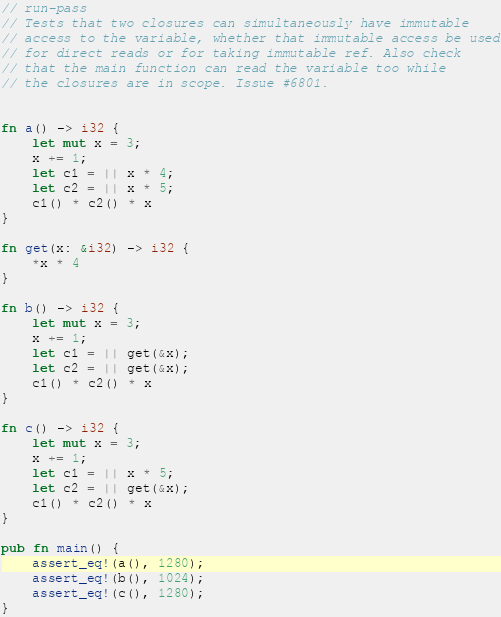<code> <loc_0><loc_0><loc_500><loc_500><_Rust_>// run-pass
// Tests that two closures can simultaneously have immutable
// access to the variable, whether that immutable access be used
// for direct reads or for taking immutable ref. Also check
// that the main function can read the variable too while
// the closures are in scope. Issue #6801.


fn a() -> i32 {
    let mut x = 3;
    x += 1;
    let c1 = || x * 4;
    let c2 = || x * 5;
    c1() * c2() * x
}

fn get(x: &i32) -> i32 {
    *x * 4
}

fn b() -> i32 {
    let mut x = 3;
    x += 1;
    let c1 = || get(&x);
    let c2 = || get(&x);
    c1() * c2() * x
}

fn c() -> i32 {
    let mut x = 3;
    x += 1;
    let c1 = || x * 5;
    let c2 = || get(&x);
    c1() * c2() * x
}

pub fn main() {
    assert_eq!(a(), 1280);
    assert_eq!(b(), 1024);
    assert_eq!(c(), 1280);
}
</code> 